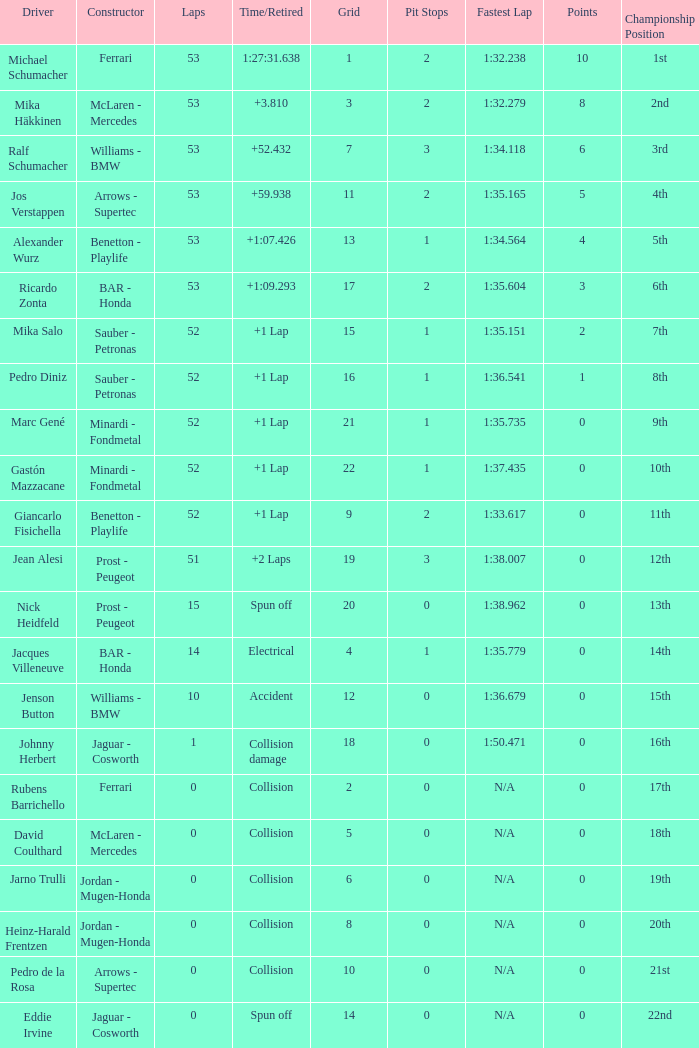What is the grid number with less than 52 laps and a Time/Retired of collision, and a Constructor of arrows - supertec? 1.0. 